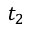<formula> <loc_0><loc_0><loc_500><loc_500>t _ { 2 }</formula> 